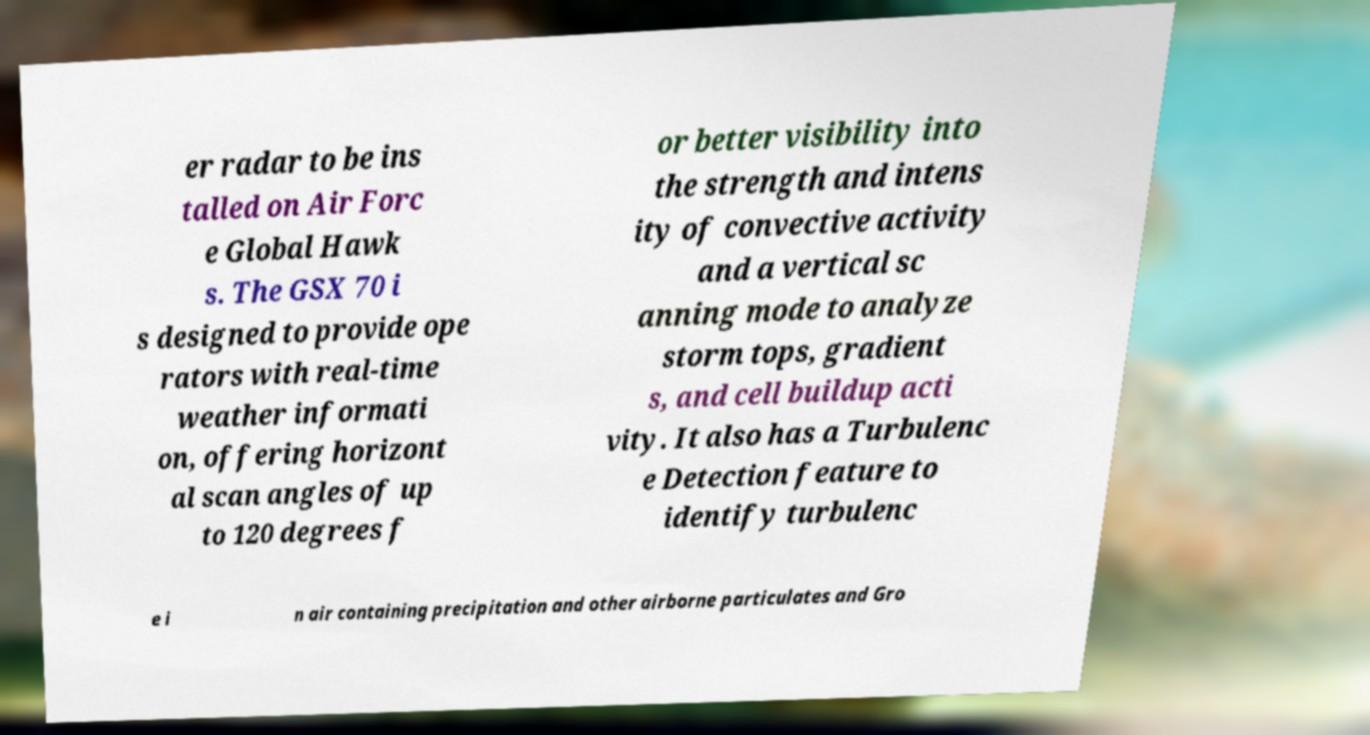Can you read and provide the text displayed in the image?This photo seems to have some interesting text. Can you extract and type it out for me? er radar to be ins talled on Air Forc e Global Hawk s. The GSX 70 i s designed to provide ope rators with real-time weather informati on, offering horizont al scan angles of up to 120 degrees f or better visibility into the strength and intens ity of convective activity and a vertical sc anning mode to analyze storm tops, gradient s, and cell buildup acti vity. It also has a Turbulenc e Detection feature to identify turbulenc e i n air containing precipitation and other airborne particulates and Gro 